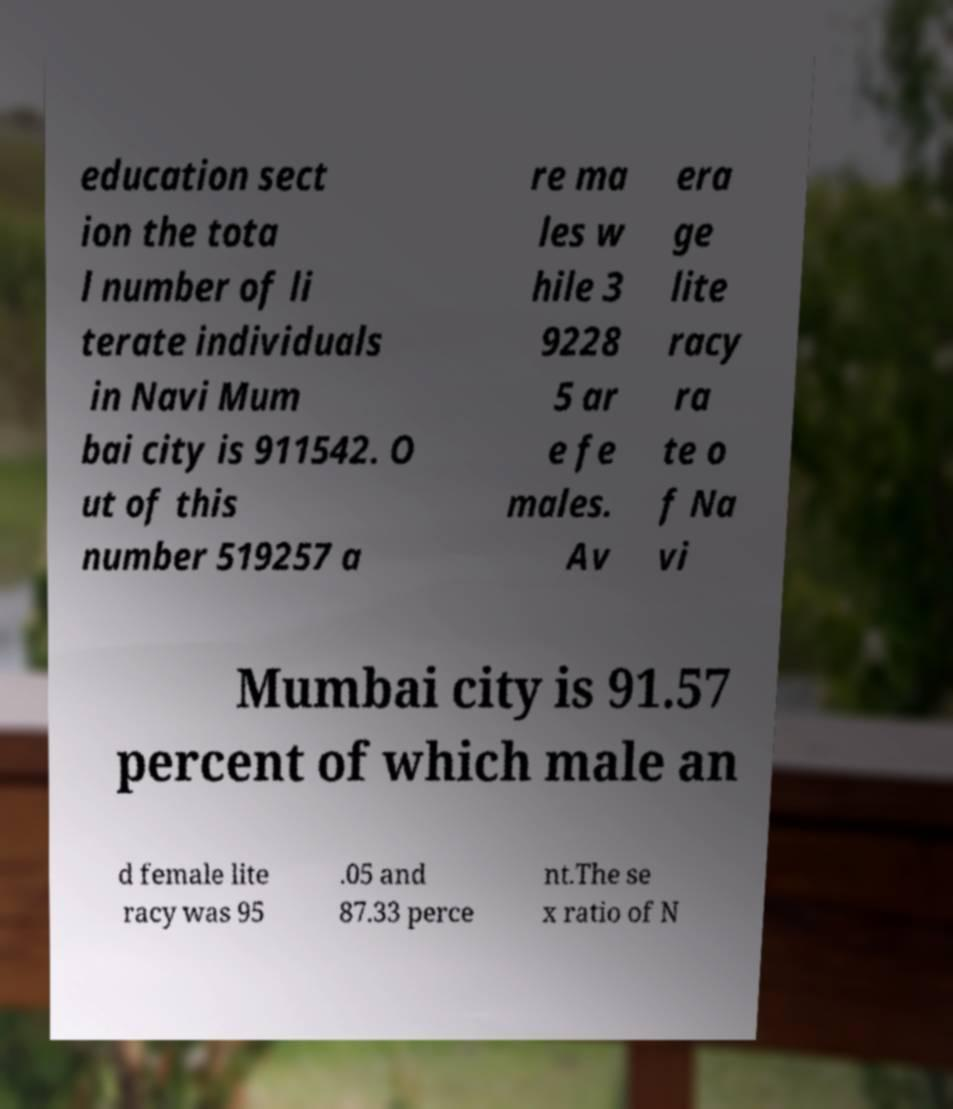I need the written content from this picture converted into text. Can you do that? education sect ion the tota l number of li terate individuals in Navi Mum bai city is 911542. O ut of this number 519257 a re ma les w hile 3 9228 5 ar e fe males. Av era ge lite racy ra te o f Na vi Mumbai city is 91.57 percent of which male an d female lite racy was 95 .05 and 87.33 perce nt.The se x ratio of N 